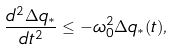Convert formula to latex. <formula><loc_0><loc_0><loc_500><loc_500>\frac { d ^ { 2 } \Delta q _ { * } } { d t ^ { 2 } } \leq - \omega ^ { 2 } _ { 0 } \Delta q _ { * } ( t ) ,</formula> 